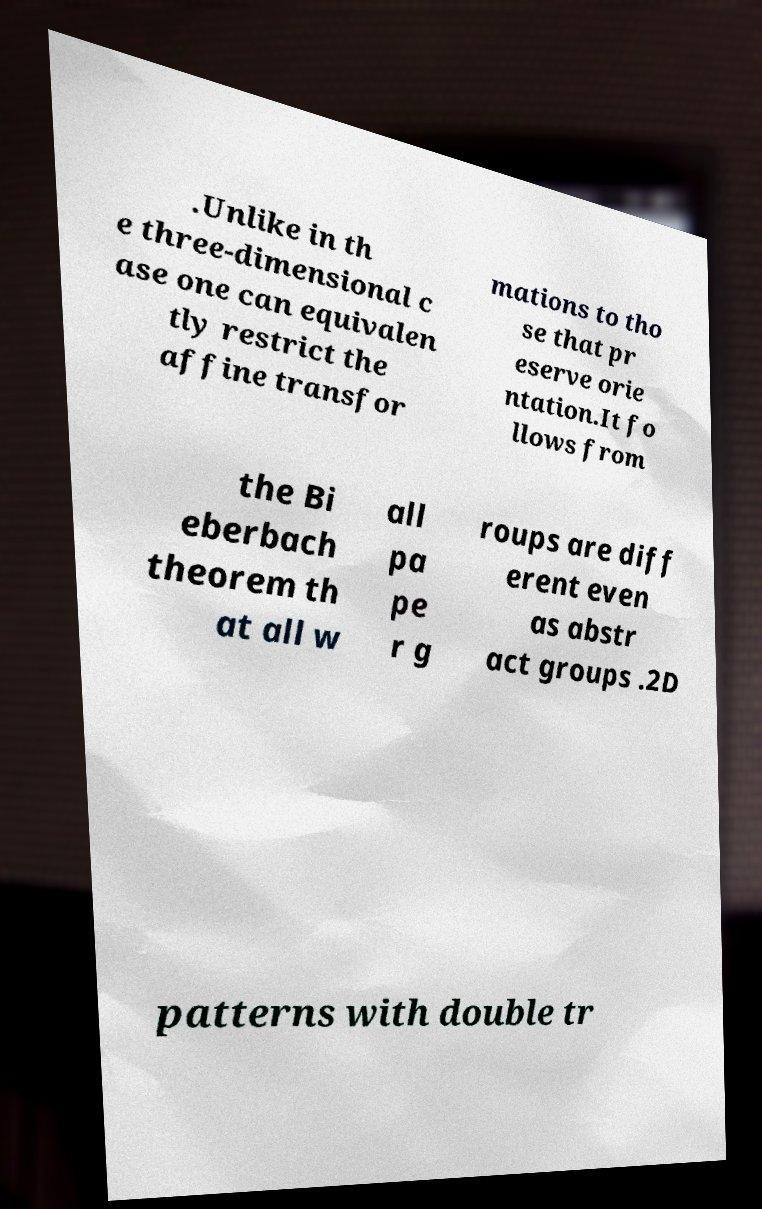Please read and relay the text visible in this image. What does it say? .Unlike in th e three-dimensional c ase one can equivalen tly restrict the affine transfor mations to tho se that pr eserve orie ntation.It fo llows from the Bi eberbach theorem th at all w all pa pe r g roups are diff erent even as abstr act groups .2D patterns with double tr 